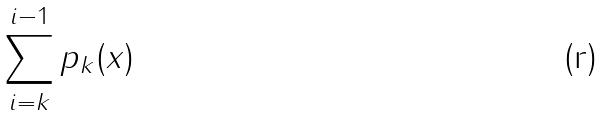<formula> <loc_0><loc_0><loc_500><loc_500>\sum _ { i = k } ^ { i - 1 } p _ { k } ( x )</formula> 